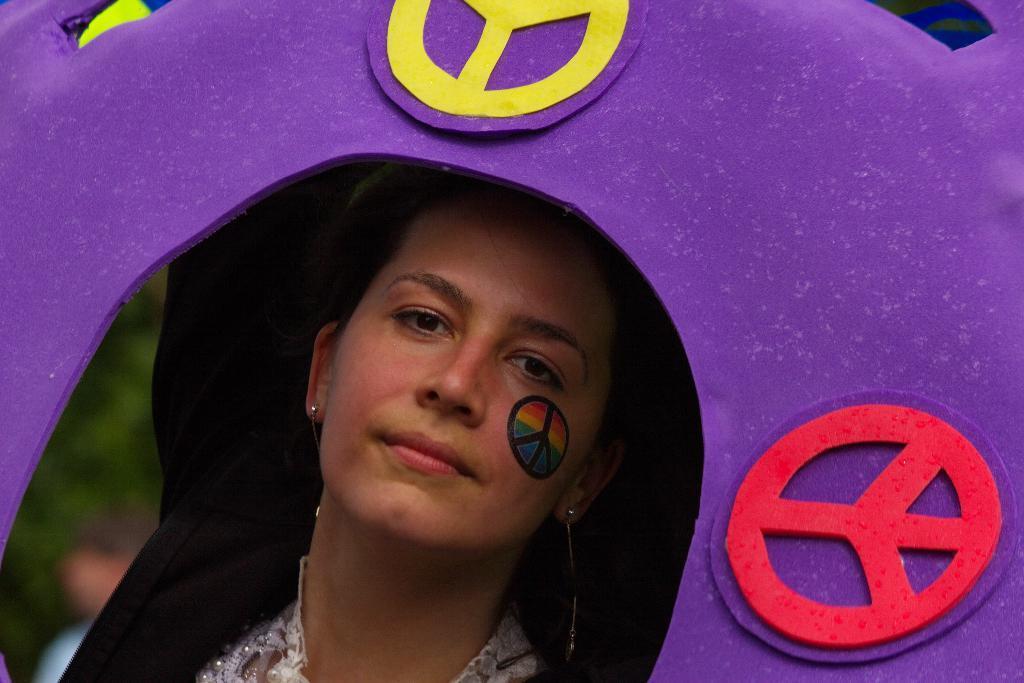In one or two sentences, can you explain what this image depicts? This image is taken outdoors. In the middle of the image there is a woman in the cave. In the background there is a person and there is a tree. 